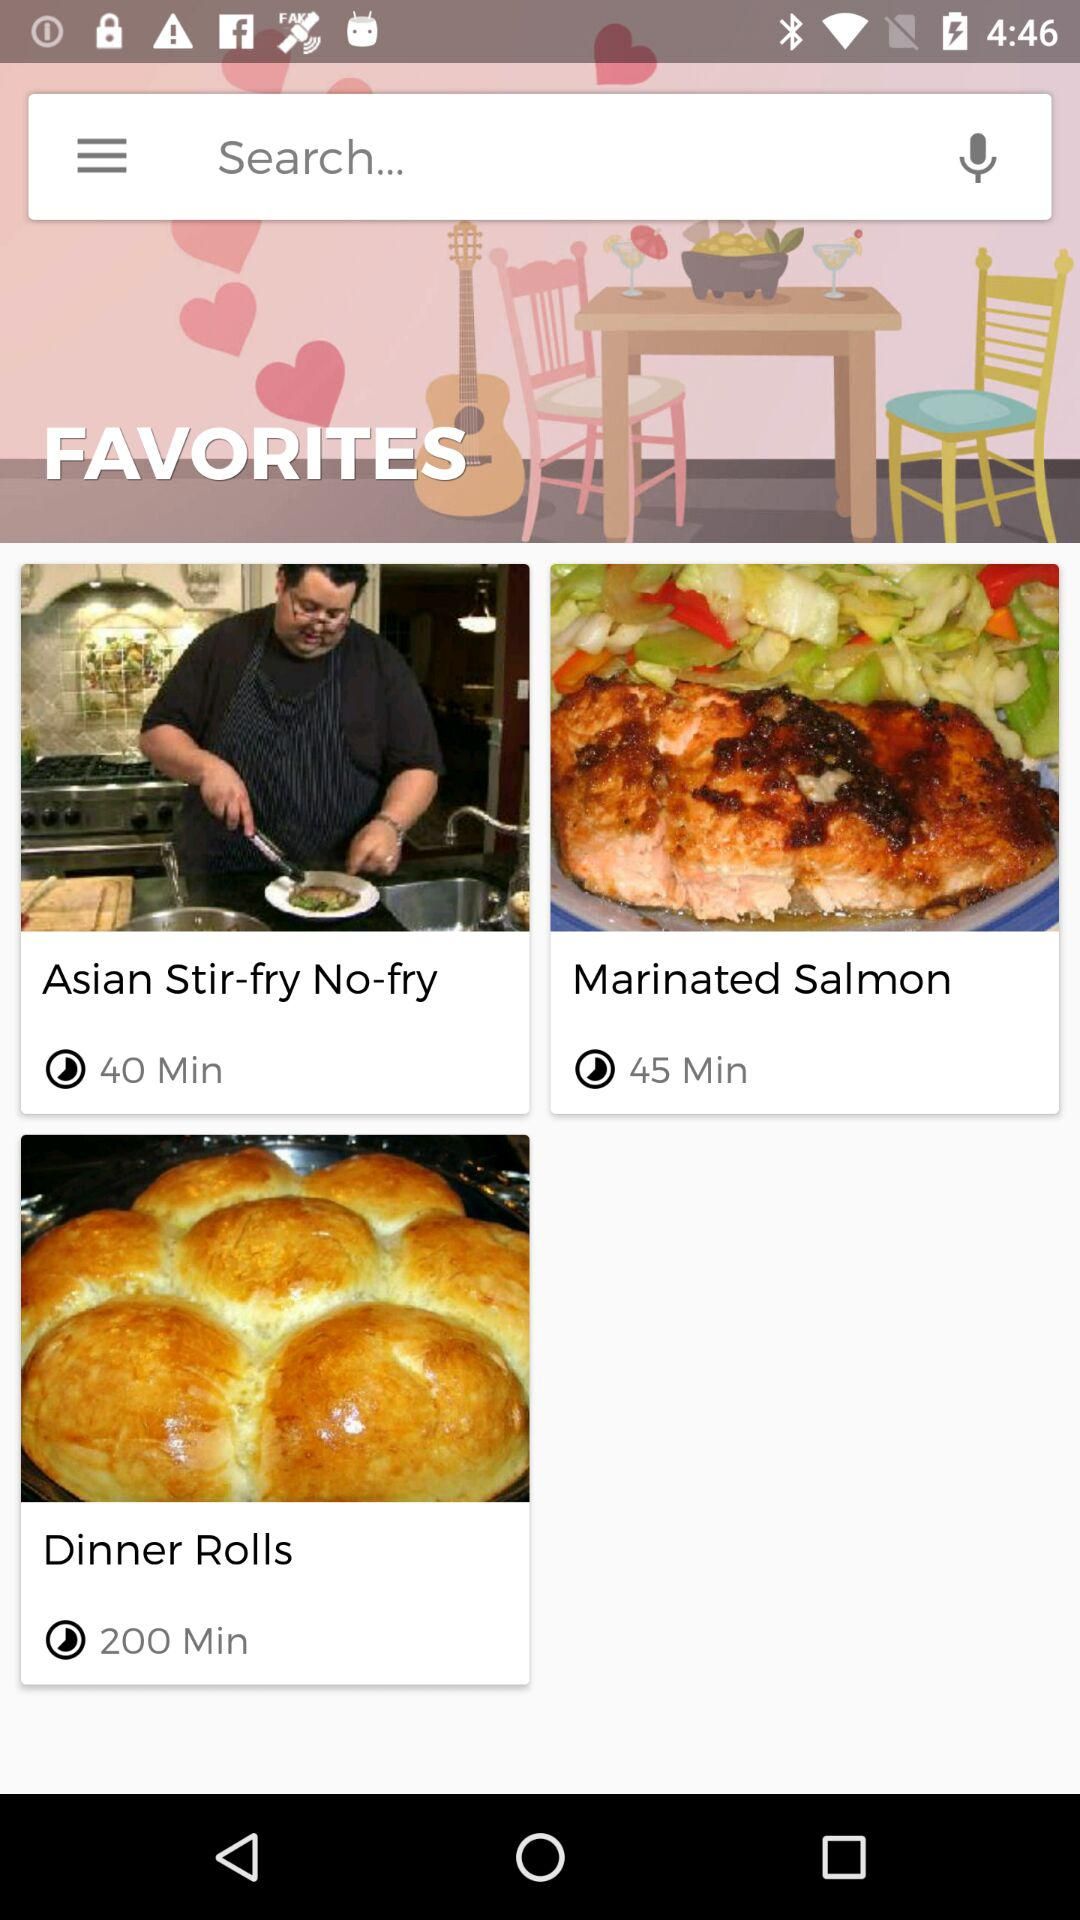Which is the longest video?
When the provided information is insufficient, respond with <no answer>. <no answer> 